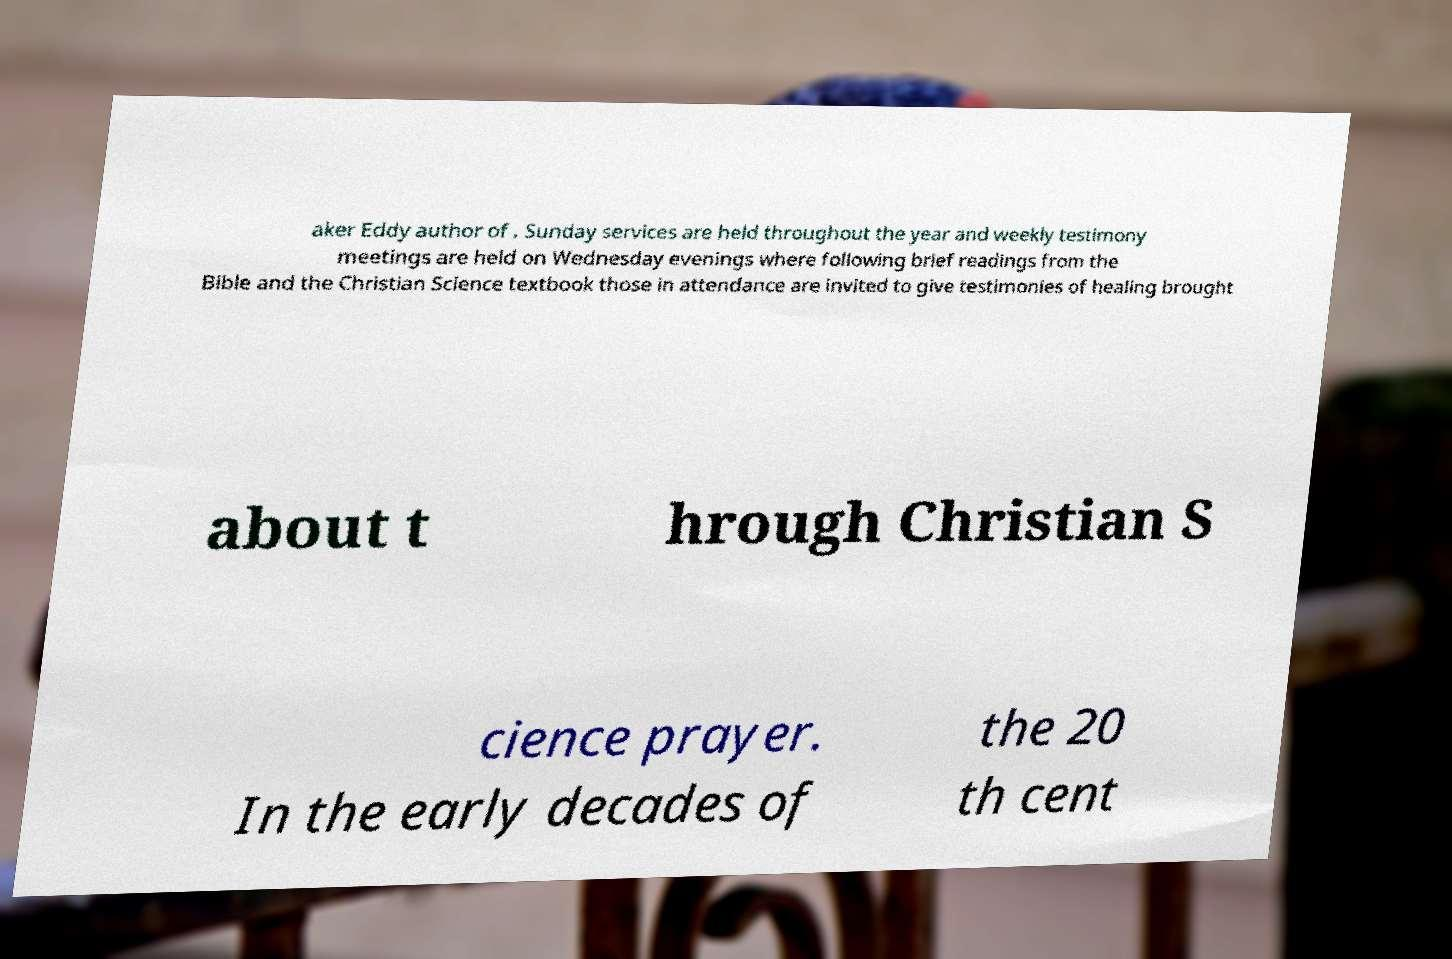I need the written content from this picture converted into text. Can you do that? aker Eddy author of . Sunday services are held throughout the year and weekly testimony meetings are held on Wednesday evenings where following brief readings from the Bible and the Christian Science textbook those in attendance are invited to give testimonies of healing brought about t hrough Christian S cience prayer. In the early decades of the 20 th cent 